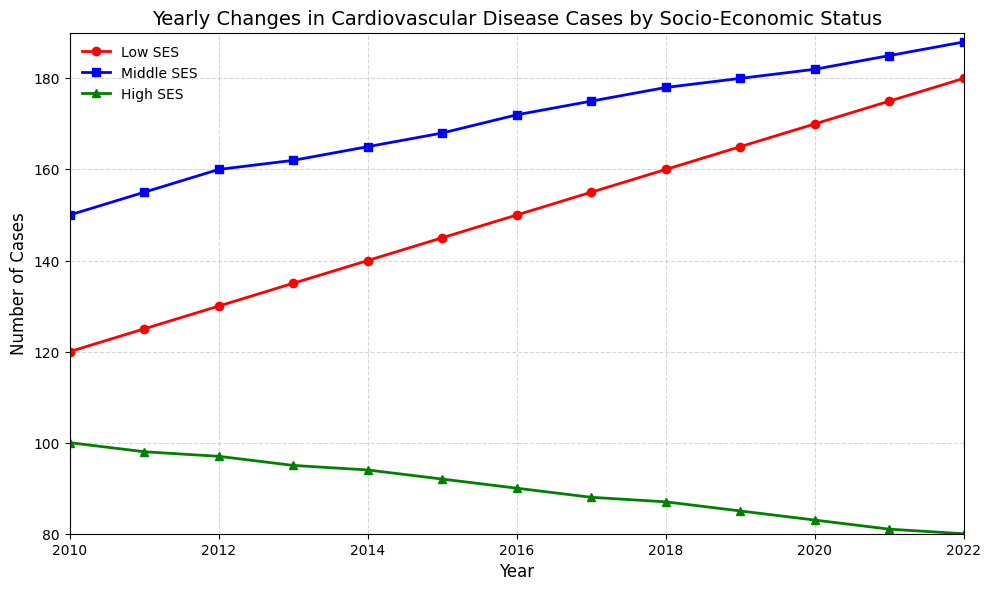Which socio-economic status category experienced the highest number of cardiovascular disease cases in 2022? Looking at the figure for the year 2022, the line representing the number of cases for Low SES (red) is at the highest point compared to Middle SES (blue) and High SES (green).
Answer: Low SES By how many cases did the cardiovascular disease cases increase from 2010 to 2022 for the Middle SES group? In 2010, the number of cases for Middle SES was 150. In 2022, it was 188. The difference is 188 - 150 = 38 cases.
Answer: 38 Which socio-economic status group saw the smallest decrease in cardiovascular disease cases from 2010 to 2022? The figures for 2010 and 2022 are: Low SES (120 to 180), Middle SES (150 to 188), and High SES (100 to 80). Middle SES showed an increase, thus has no decrease. So, we compare Low SES (180 - 120 = 60 increase) and High SES (100 - 80 = 20 decrease). The smallest decrease among those that decreased is High SES with a decrease of 20 cases.
Answer: High SES In which year did the number of cardiovascular disease cases for Low SES first exceed 150? Following the trend line for Low SES, it first exceeds 150 in 2016.
Answer: 2016 From 2010 to 2022, which socio-economic status had the steepest increase in cardiovascular disease cases and by how much? Observe the increase from 2010 to 2022 for all socio-economic statuses: Low SES increases by 180 - 120 = 60, Middle SES by 188 - 150 = 38, and High SES decreases. The steepest increase is in Low SES with 60 cases.
Answer: Low SES by 60 What is the average number of cardiovascular disease cases for High SES over the years 2010 to 2022? Sum the yearly values for High SES: 100 + 98 + 97 + 95 + 94 + 92 + 90 + 88 + 87 + 85 + 83 + 81 + 80 = 1260. There are 13 years. Calculate the average: 1260 / 13 = 96.92 cases.
Answer: 96.92 cases Between which consecutive years did the Middle SES group see the largest increase in cardiovascular disease cases? Observing the annual changes in Middle SES: 2010-2011 (+5), 2011-2012 (+5), 2012-2013 (+2), 2013-2014 (+3), 2014-2015 (+3), 2015-2016 (+4), 2016-2017 (+3), 2017-2018 (+3), 2018-2019 (+2), 2019-2020 (+2), 2020-2021 (+3), and 2021-2022 (+3). The largest increase is from 2011 to 2012 with an increase of 5 cases.
Answer: 2011-2012 Compare the trend lines for Middle SES and High SES, which category experienced a generally opposite trend over the years? Middle SES shows a general upward trend in cases, while High SES shows a steady downward trend. Hence, High SES experienced the opposite trend to Middle SES.
Answer: High SES 